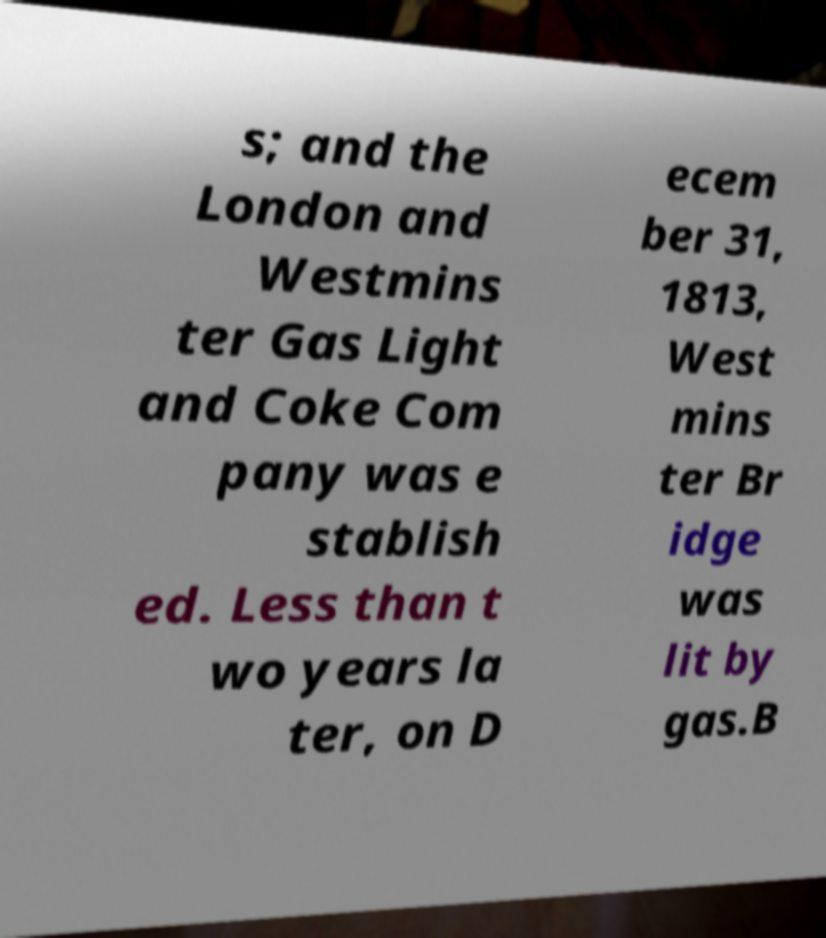Can you accurately transcribe the text from the provided image for me? s; and the London and Westmins ter Gas Light and Coke Com pany was e stablish ed. Less than t wo years la ter, on D ecem ber 31, 1813, West mins ter Br idge was lit by gas.B 